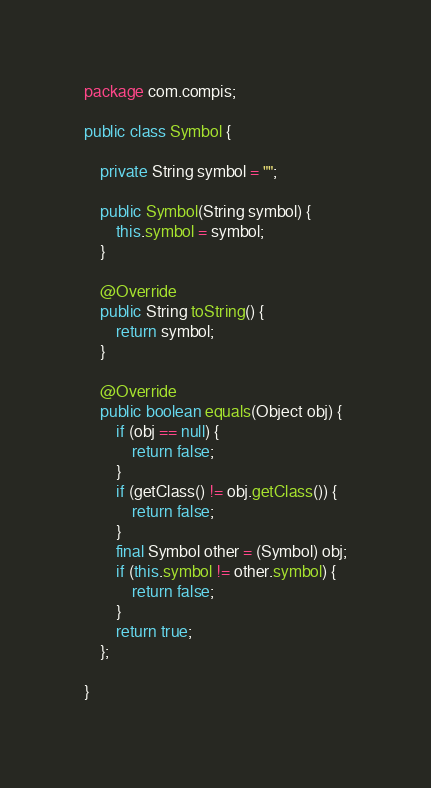<code> <loc_0><loc_0><loc_500><loc_500><_Java_>package com.compis;

public class Symbol {
	
	private String symbol = "";
	
	public Symbol(String symbol) {
		this.symbol = symbol;
	}
	
	@Override
	public String toString() {
		return symbol;
	}
	
	@Override
	public boolean equals(Object obj) {
		if (obj == null) {
	        return false;
	    }
	    if (getClass() != obj.getClass()) {
	        return false;
	    }
	    final Symbol other = (Symbol) obj;
	    if (this.symbol != other.symbol) {
	        return false;
	    }
	    return true;
	};

}
</code> 